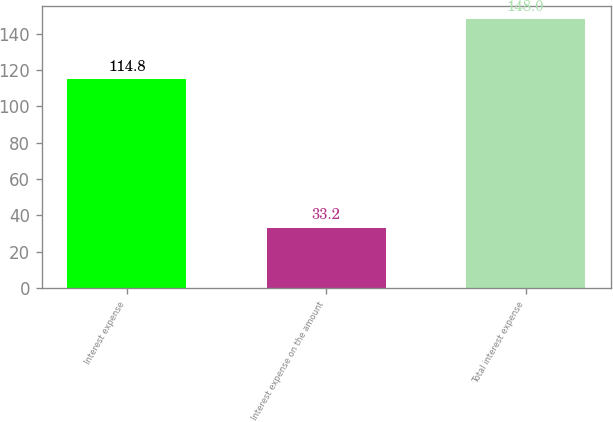<chart> <loc_0><loc_0><loc_500><loc_500><bar_chart><fcel>Interest expense<fcel>Interest expense on the amount<fcel>Total interest expense<nl><fcel>114.8<fcel>33.2<fcel>148<nl></chart> 